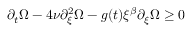<formula> <loc_0><loc_0><loc_500><loc_500>\partial _ { t } \Omega - 4 \nu \partial _ { \xi } ^ { 2 } \Omega - g ( t ) \xi ^ { \beta } \partial _ { \xi } \Omega \geq 0</formula> 